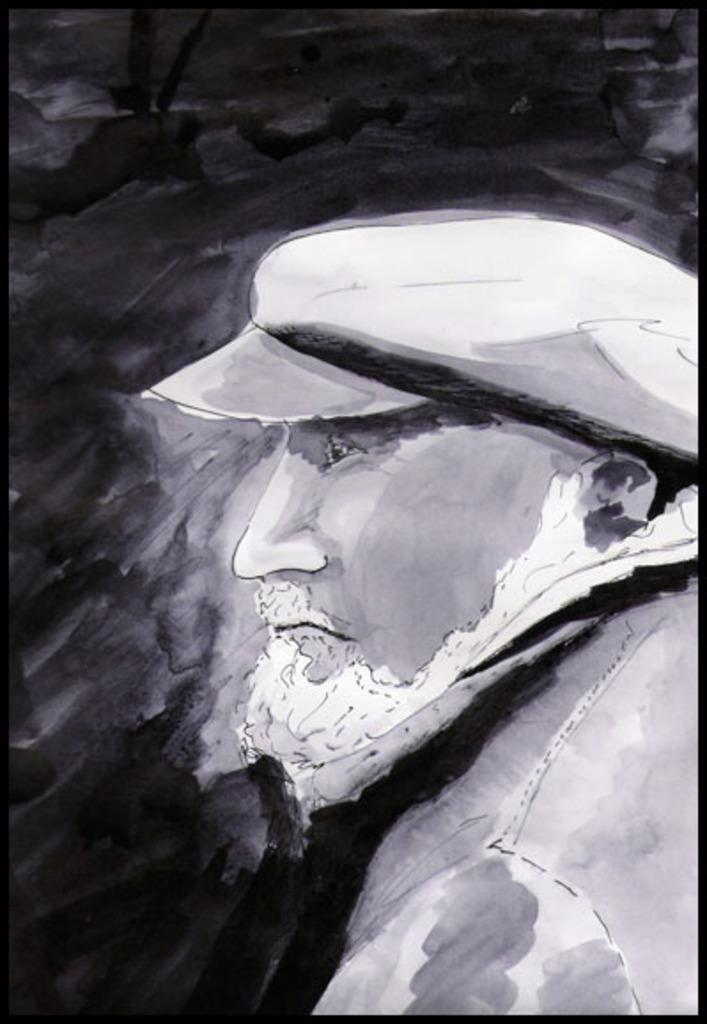What is the main subject of the image? The image contains a painting. What can be said about the color scheme of the painting? The painting is black and white in color. Who or what is depicted in the painting? There is a person depicted in the painting. What is the person wearing in the painting? The person is wearing clothes and a cap. How many houses are visible in the painting? There are no houses visible in the painting; it features a person wearing clothes and a cap. What type of crate is being used by the person in the painting? There is no crate present in the painting; it only depicts a person wearing clothes and a cap. 